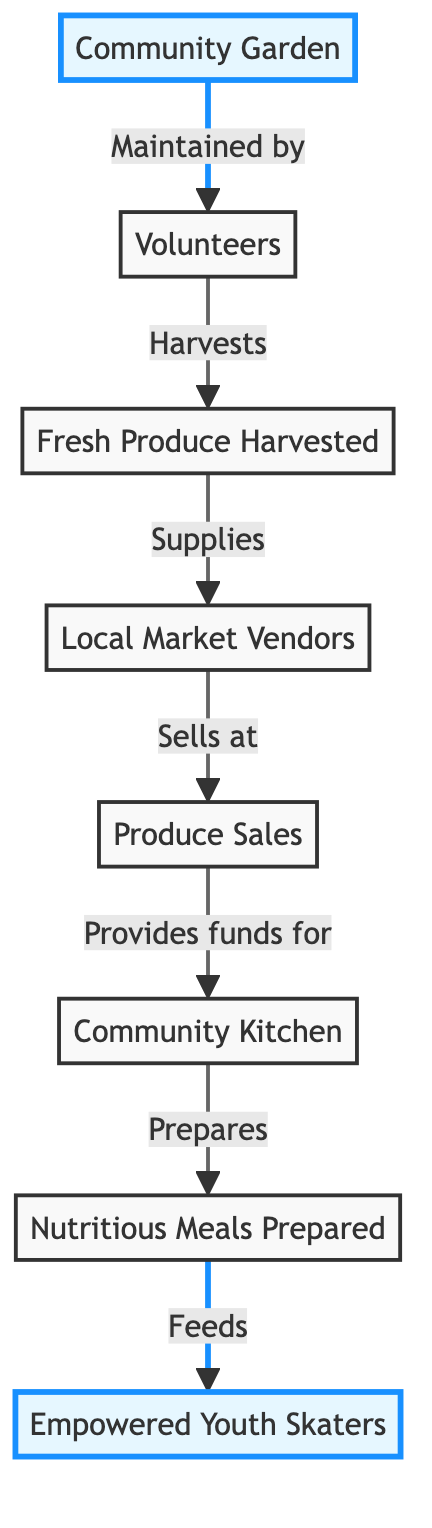What is the starting point of the flow in the diagram? The starting point is labeled as the "Community Garden," which is the first node in the diagram.
Answer: Community Garden How many nodes are there in total? By counting each labeled box in the diagram, there are seven distinct nodes present.
Answer: 7 Who maintains the community garden? The community garden is maintained by "Volunteers," as indicated by the direct connection from the garden to volunteers.
Answer: Volunteers What is supplied by the fresh produce harvested? The fresh produce harvested supplies "Local Market Vendors," forming a direct relationship between these two nodes.
Answer: Local Market Vendors What do the produce sales provide funding for? The produce sales provide funds for the "Community Kitchen," which is shown as the subsequent node after the sales.
Answer: Community Kitchen Describe how nutritious meals are prepared. Nutritious meals are prepared in the "Community Kitchen," which the diagram shows is connected after the produce sales.
Answer: Community Kitchen How does the flow of the diagram ultimately benefit the youth skaters? The flow leads from "Nutritious Meals Prepared" to "Empowered Youth Skaters," indicating that the meals are meant to feed and empower these skaters.
Answer: Empowered Youth Skaters What two functions do the volunteers serve in the diagram? The volunteers maintain the community garden and harvest the fresh produce, linking their role to both the garden and the produce.
Answer: Maintain & Harvest What is the final output of the food chain represented in the diagram? The final output of the food chain is the "Empowered Youth Skaters," as they are the last node that receives nourishment from the community efforts.
Answer: Empowered Youth Skaters 